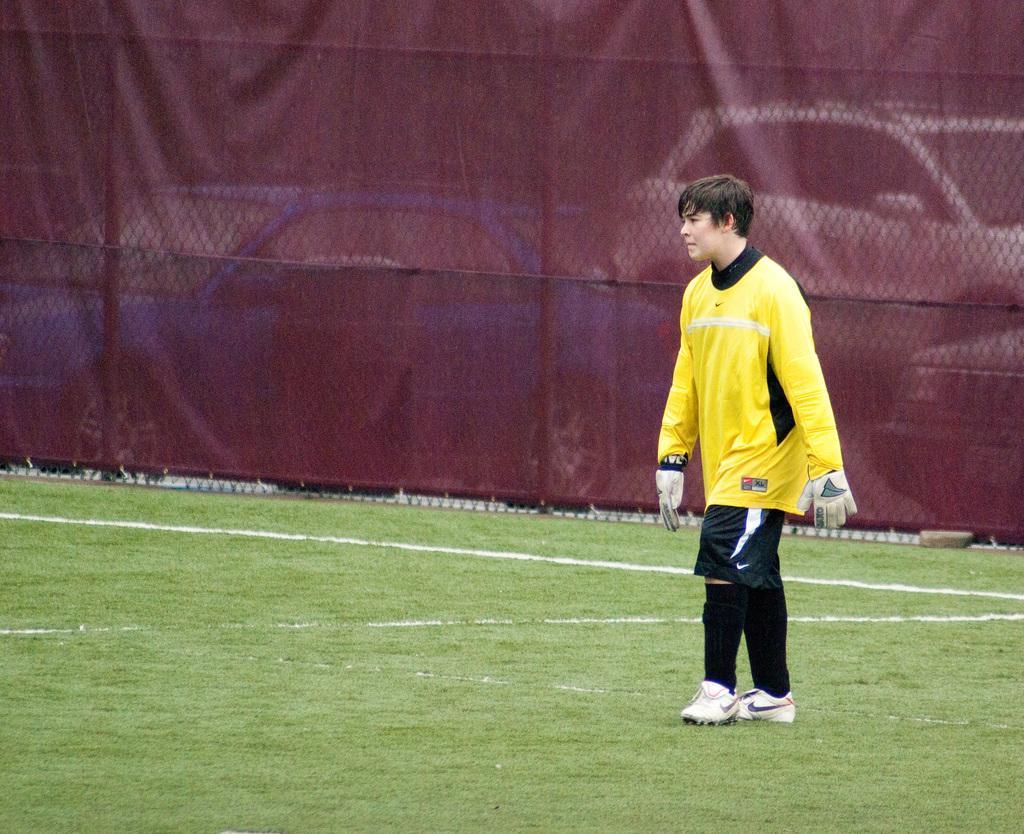Could you give a brief overview of what you see in this image? There is a boy on the right side of the image on the grassland and there is a net, curtain and cars in the background area, it seems like trees behind the cars. 